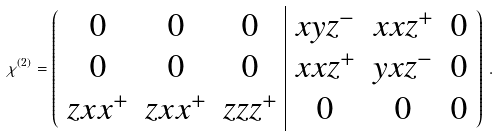Convert formula to latex. <formula><loc_0><loc_0><loc_500><loc_500>\chi ^ { ( 2 ) } = \left ( \begin{array} { c c c | c c c } 0 & 0 & 0 & x y z ^ { - } & x x z ^ { + } & 0 \\ 0 & 0 & 0 & x x z ^ { + } & y x z ^ { - } & 0 \\ z x x ^ { + } & z x x ^ { + } & z z z ^ { + } & 0 & 0 & 0 \end{array} \right ) \, .</formula> 